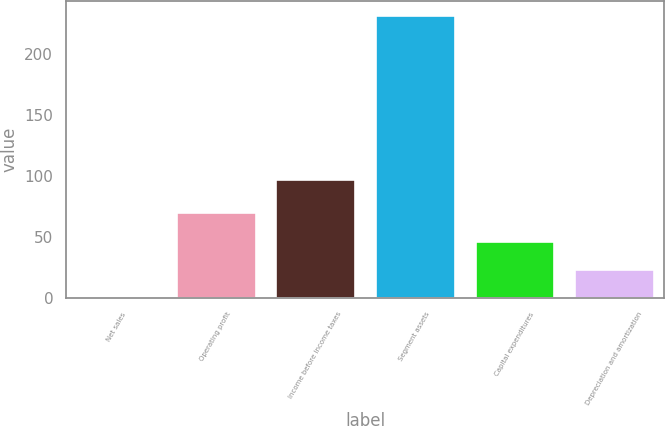Convert chart. <chart><loc_0><loc_0><loc_500><loc_500><bar_chart><fcel>Net sales<fcel>Operating profit<fcel>Income before income taxes<fcel>Segment assets<fcel>Capital expenditures<fcel>Depreciation and amortization<nl><fcel>0.8<fcel>70.8<fcel>97.3<fcel>232<fcel>47.04<fcel>23.92<nl></chart> 